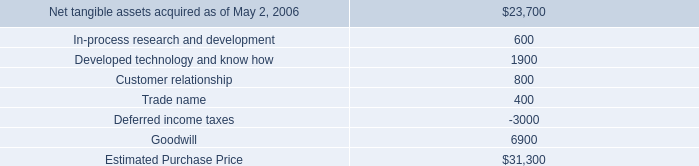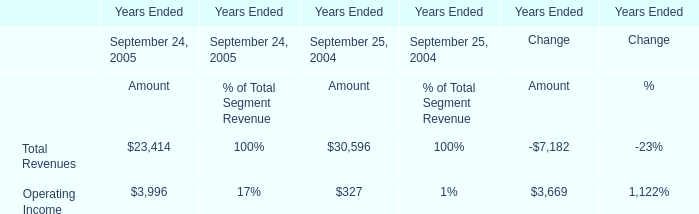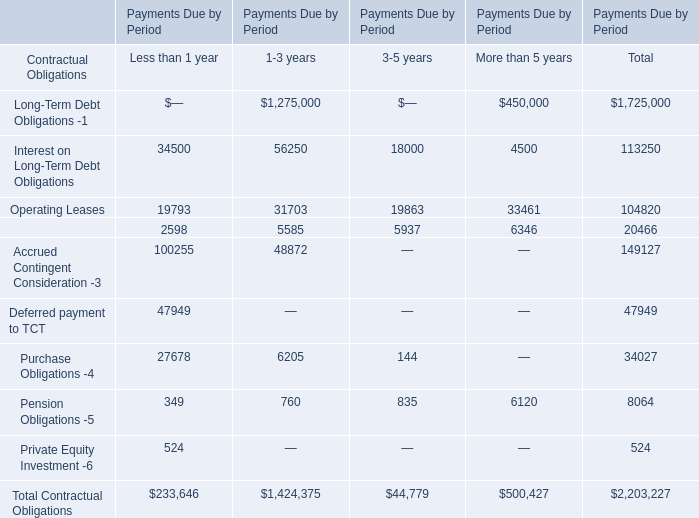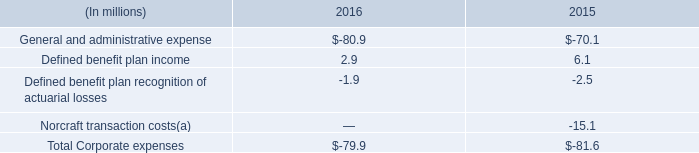What is the proportion of Interest on Long-Term Debt Obligations to the total in for Less than 1 year ? 
Computations: (34500 / 233646)
Answer: 0.14766. 